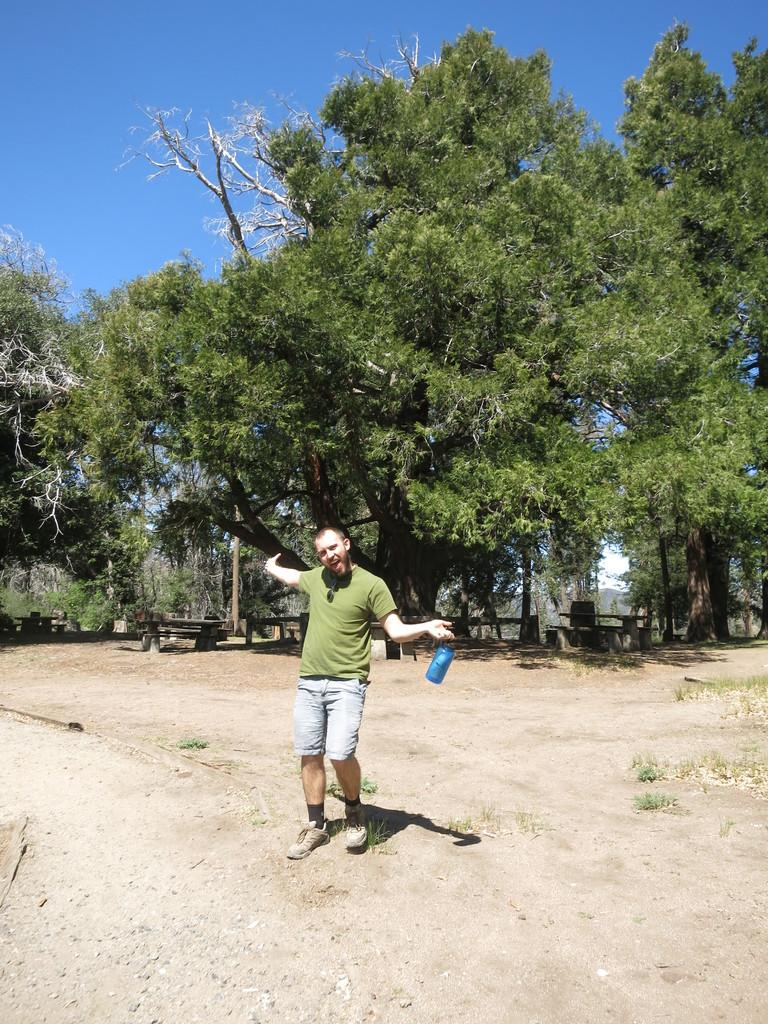What is the main subject of the image? The main subject of the image is a man. What is the man holding in the image? The man is holding a bottle with his hand. What can be seen in the background of the image? There are trees and the sky visible in the background of the image. What type of meat is being transported on the railway in the image? There is no railway or meat present in the image; it features a man holding a bottle with trees and the sky in the background. 